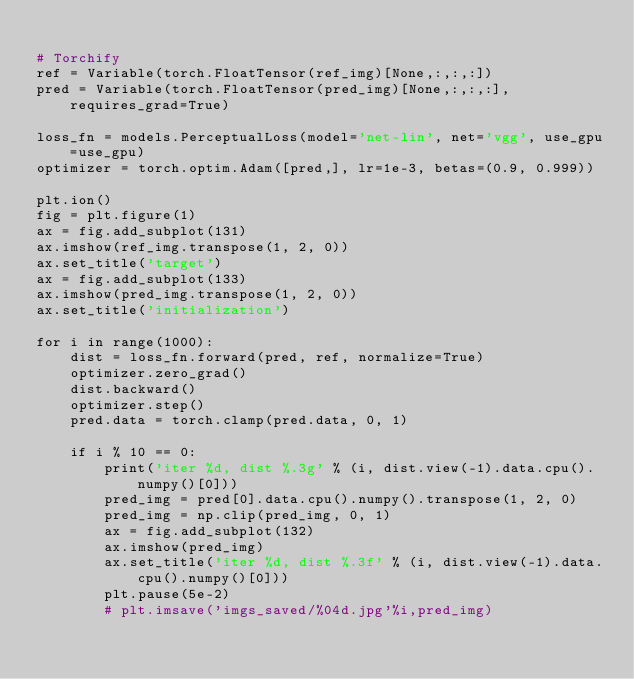Convert code to text. <code><loc_0><loc_0><loc_500><loc_500><_Python_>
# Torchify
ref = Variable(torch.FloatTensor(ref_img)[None,:,:,:])
pred = Variable(torch.FloatTensor(pred_img)[None,:,:,:], requires_grad=True)

loss_fn = models.PerceptualLoss(model='net-lin', net='vgg', use_gpu=use_gpu)
optimizer = torch.optim.Adam([pred,], lr=1e-3, betas=(0.9, 0.999))

plt.ion()
fig = plt.figure(1)
ax = fig.add_subplot(131)
ax.imshow(ref_img.transpose(1, 2, 0))
ax.set_title('target')
ax = fig.add_subplot(133)
ax.imshow(pred_img.transpose(1, 2, 0))
ax.set_title('initialization')

for i in range(1000):
    dist = loss_fn.forward(pred, ref, normalize=True)
    optimizer.zero_grad()
    dist.backward()
    optimizer.step()
    pred.data = torch.clamp(pred.data, 0, 1)
    
    if i % 10 == 0:
        print('iter %d, dist %.3g' % (i, dist.view(-1).data.cpu().numpy()[0]))
        pred_img = pred[0].data.cpu().numpy().transpose(1, 2, 0)
        pred_img = np.clip(pred_img, 0, 1)
        ax = fig.add_subplot(132)            
        ax.imshow(pred_img)
        ax.set_title('iter %d, dist %.3f' % (i, dist.view(-1).data.cpu().numpy()[0]))
        plt.pause(5e-2)
        # plt.imsave('imgs_saved/%04d.jpg'%i,pred_img)


</code> 